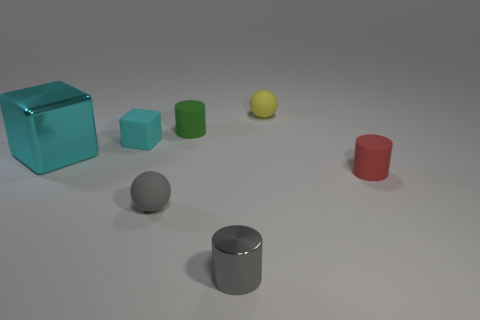There is a big metal thing; does it have the same shape as the cyan thing that is to the right of the large cyan metallic object?
Give a very brief answer. Yes. What number of things are either balls behind the cyan metal thing or rubber spheres in front of the matte cube?
Your answer should be compact. 2. Is the number of yellow rubber objects in front of the cyan rubber block less than the number of red rubber cubes?
Offer a terse response. No. Do the small gray ball and the sphere behind the matte block have the same material?
Make the answer very short. Yes. What material is the green object?
Provide a succinct answer. Rubber. What is the material of the thing that is right of the sphere behind the metallic thing that is behind the shiny cylinder?
Ensure brevity in your answer.  Rubber. Do the big thing and the small thing to the left of the tiny gray rubber thing have the same color?
Ensure brevity in your answer.  Yes. What color is the tiny matte sphere behind the gray thing that is behind the tiny gray metal thing?
Your response must be concise. Yellow. What number of big cyan matte cubes are there?
Offer a terse response. 0. How many metal things are either small balls or green things?
Your response must be concise. 0. 